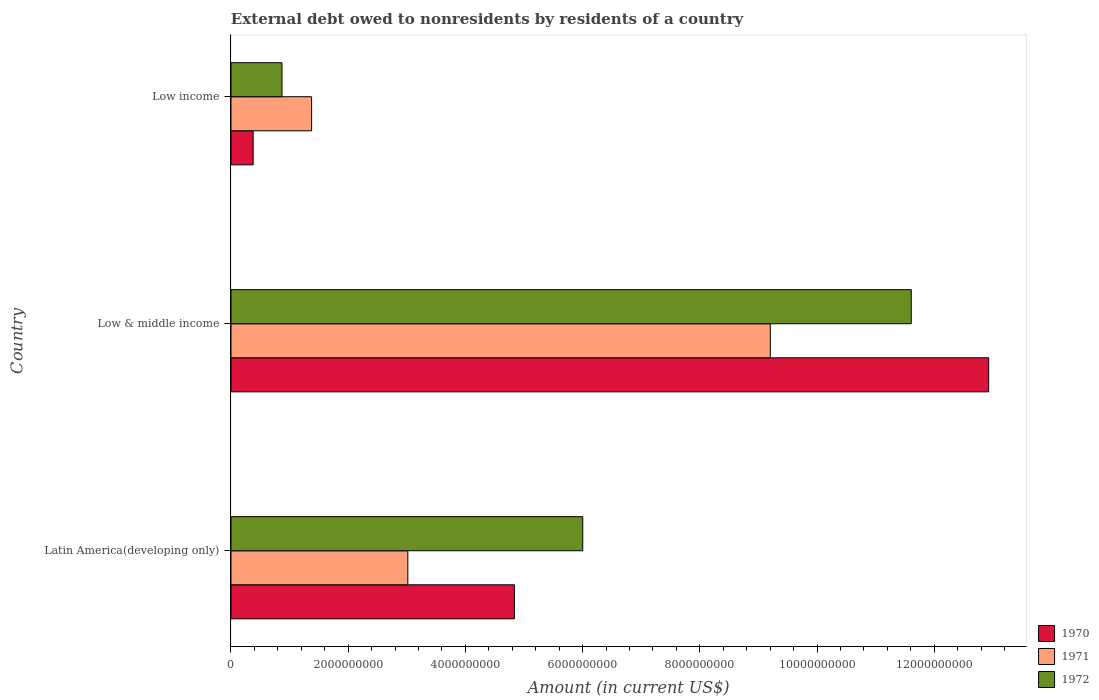How many different coloured bars are there?
Ensure brevity in your answer.  3. Are the number of bars per tick equal to the number of legend labels?
Offer a terse response. Yes. How many bars are there on the 1st tick from the top?
Provide a succinct answer. 3. In how many cases, is the number of bars for a given country not equal to the number of legend labels?
Provide a succinct answer. 0. What is the external debt owed by residents in 1972 in Latin America(developing only)?
Keep it short and to the point. 6.00e+09. Across all countries, what is the maximum external debt owed by residents in 1970?
Your response must be concise. 1.29e+1. Across all countries, what is the minimum external debt owed by residents in 1972?
Offer a very short reply. 8.71e+08. In which country was the external debt owed by residents in 1971 minimum?
Offer a very short reply. Low income. What is the total external debt owed by residents in 1972 in the graph?
Offer a very short reply. 1.85e+1. What is the difference between the external debt owed by residents in 1971 in Latin America(developing only) and that in Low & middle income?
Provide a short and direct response. -6.18e+09. What is the difference between the external debt owed by residents in 1971 in Latin America(developing only) and the external debt owed by residents in 1972 in Low & middle income?
Offer a very short reply. -8.59e+09. What is the average external debt owed by residents in 1972 per country?
Keep it short and to the point. 6.16e+09. What is the difference between the external debt owed by residents in 1972 and external debt owed by residents in 1971 in Latin America(developing only)?
Provide a succinct answer. 2.98e+09. In how many countries, is the external debt owed by residents in 1970 greater than 11600000000 US$?
Make the answer very short. 1. What is the ratio of the external debt owed by residents in 1972 in Latin America(developing only) to that in Low income?
Offer a very short reply. 6.89. Is the external debt owed by residents in 1971 in Latin America(developing only) less than that in Low & middle income?
Give a very brief answer. Yes. Is the difference between the external debt owed by residents in 1972 in Latin America(developing only) and Low & middle income greater than the difference between the external debt owed by residents in 1971 in Latin America(developing only) and Low & middle income?
Provide a short and direct response. Yes. What is the difference between the highest and the second highest external debt owed by residents in 1971?
Your answer should be very brief. 6.18e+09. What is the difference between the highest and the lowest external debt owed by residents in 1971?
Your answer should be compact. 7.83e+09. What is the difference between two consecutive major ticks on the X-axis?
Keep it short and to the point. 2.00e+09. Are the values on the major ticks of X-axis written in scientific E-notation?
Offer a terse response. No. Where does the legend appear in the graph?
Make the answer very short. Bottom right. How many legend labels are there?
Offer a very short reply. 3. How are the legend labels stacked?
Keep it short and to the point. Vertical. What is the title of the graph?
Give a very brief answer. External debt owed to nonresidents by residents of a country. What is the Amount (in current US$) of 1970 in Latin America(developing only)?
Ensure brevity in your answer.  4.84e+09. What is the Amount (in current US$) of 1971 in Latin America(developing only)?
Provide a short and direct response. 3.02e+09. What is the Amount (in current US$) in 1972 in Latin America(developing only)?
Ensure brevity in your answer.  6.00e+09. What is the Amount (in current US$) of 1970 in Low & middle income?
Provide a short and direct response. 1.29e+1. What is the Amount (in current US$) in 1971 in Low & middle income?
Offer a very short reply. 9.20e+09. What is the Amount (in current US$) in 1972 in Low & middle income?
Your response must be concise. 1.16e+1. What is the Amount (in current US$) in 1970 in Low income?
Keep it short and to the point. 3.78e+08. What is the Amount (in current US$) in 1971 in Low income?
Provide a succinct answer. 1.38e+09. What is the Amount (in current US$) in 1972 in Low income?
Your response must be concise. 8.71e+08. Across all countries, what is the maximum Amount (in current US$) in 1970?
Your answer should be compact. 1.29e+1. Across all countries, what is the maximum Amount (in current US$) of 1971?
Make the answer very short. 9.20e+09. Across all countries, what is the maximum Amount (in current US$) of 1972?
Offer a very short reply. 1.16e+1. Across all countries, what is the minimum Amount (in current US$) in 1970?
Offer a very short reply. 3.78e+08. Across all countries, what is the minimum Amount (in current US$) in 1971?
Your answer should be compact. 1.38e+09. Across all countries, what is the minimum Amount (in current US$) of 1972?
Ensure brevity in your answer.  8.71e+08. What is the total Amount (in current US$) of 1970 in the graph?
Your response must be concise. 1.81e+1. What is the total Amount (in current US$) in 1971 in the graph?
Provide a succinct answer. 1.36e+1. What is the total Amount (in current US$) of 1972 in the graph?
Offer a terse response. 1.85e+1. What is the difference between the Amount (in current US$) in 1970 in Latin America(developing only) and that in Low & middle income?
Give a very brief answer. -8.09e+09. What is the difference between the Amount (in current US$) of 1971 in Latin America(developing only) and that in Low & middle income?
Your answer should be very brief. -6.18e+09. What is the difference between the Amount (in current US$) of 1972 in Latin America(developing only) and that in Low & middle income?
Your answer should be very brief. -5.61e+09. What is the difference between the Amount (in current US$) in 1970 in Latin America(developing only) and that in Low income?
Give a very brief answer. 4.46e+09. What is the difference between the Amount (in current US$) of 1971 in Latin America(developing only) and that in Low income?
Your answer should be very brief. 1.64e+09. What is the difference between the Amount (in current US$) in 1972 in Latin America(developing only) and that in Low income?
Give a very brief answer. 5.13e+09. What is the difference between the Amount (in current US$) in 1970 in Low & middle income and that in Low income?
Your answer should be very brief. 1.25e+1. What is the difference between the Amount (in current US$) of 1971 in Low & middle income and that in Low income?
Your response must be concise. 7.83e+09. What is the difference between the Amount (in current US$) in 1972 in Low & middle income and that in Low income?
Provide a short and direct response. 1.07e+1. What is the difference between the Amount (in current US$) in 1970 in Latin America(developing only) and the Amount (in current US$) in 1971 in Low & middle income?
Your response must be concise. -4.37e+09. What is the difference between the Amount (in current US$) in 1970 in Latin America(developing only) and the Amount (in current US$) in 1972 in Low & middle income?
Offer a very short reply. -6.77e+09. What is the difference between the Amount (in current US$) in 1971 in Latin America(developing only) and the Amount (in current US$) in 1972 in Low & middle income?
Make the answer very short. -8.59e+09. What is the difference between the Amount (in current US$) of 1970 in Latin America(developing only) and the Amount (in current US$) of 1971 in Low income?
Your answer should be compact. 3.46e+09. What is the difference between the Amount (in current US$) in 1970 in Latin America(developing only) and the Amount (in current US$) in 1972 in Low income?
Your answer should be compact. 3.97e+09. What is the difference between the Amount (in current US$) of 1971 in Latin America(developing only) and the Amount (in current US$) of 1972 in Low income?
Provide a short and direct response. 2.15e+09. What is the difference between the Amount (in current US$) of 1970 in Low & middle income and the Amount (in current US$) of 1971 in Low income?
Provide a succinct answer. 1.16e+1. What is the difference between the Amount (in current US$) in 1970 in Low & middle income and the Amount (in current US$) in 1972 in Low income?
Your answer should be very brief. 1.21e+1. What is the difference between the Amount (in current US$) in 1971 in Low & middle income and the Amount (in current US$) in 1972 in Low income?
Offer a very short reply. 8.33e+09. What is the average Amount (in current US$) in 1970 per country?
Provide a short and direct response. 6.05e+09. What is the average Amount (in current US$) of 1971 per country?
Keep it short and to the point. 4.53e+09. What is the average Amount (in current US$) of 1972 per country?
Ensure brevity in your answer.  6.16e+09. What is the difference between the Amount (in current US$) of 1970 and Amount (in current US$) of 1971 in Latin America(developing only)?
Give a very brief answer. 1.82e+09. What is the difference between the Amount (in current US$) of 1970 and Amount (in current US$) of 1972 in Latin America(developing only)?
Offer a terse response. -1.17e+09. What is the difference between the Amount (in current US$) of 1971 and Amount (in current US$) of 1972 in Latin America(developing only)?
Provide a succinct answer. -2.98e+09. What is the difference between the Amount (in current US$) in 1970 and Amount (in current US$) in 1971 in Low & middle income?
Your answer should be compact. 3.73e+09. What is the difference between the Amount (in current US$) of 1970 and Amount (in current US$) of 1972 in Low & middle income?
Provide a succinct answer. 1.32e+09. What is the difference between the Amount (in current US$) in 1971 and Amount (in current US$) in 1972 in Low & middle income?
Your response must be concise. -2.41e+09. What is the difference between the Amount (in current US$) of 1970 and Amount (in current US$) of 1971 in Low income?
Make the answer very short. -9.97e+08. What is the difference between the Amount (in current US$) of 1970 and Amount (in current US$) of 1972 in Low income?
Provide a short and direct response. -4.92e+08. What is the difference between the Amount (in current US$) in 1971 and Amount (in current US$) in 1972 in Low income?
Provide a succinct answer. 5.05e+08. What is the ratio of the Amount (in current US$) in 1970 in Latin America(developing only) to that in Low & middle income?
Give a very brief answer. 0.37. What is the ratio of the Amount (in current US$) of 1971 in Latin America(developing only) to that in Low & middle income?
Offer a very short reply. 0.33. What is the ratio of the Amount (in current US$) of 1972 in Latin America(developing only) to that in Low & middle income?
Give a very brief answer. 0.52. What is the ratio of the Amount (in current US$) in 1970 in Latin America(developing only) to that in Low income?
Provide a succinct answer. 12.78. What is the ratio of the Amount (in current US$) of 1971 in Latin America(developing only) to that in Low income?
Keep it short and to the point. 2.19. What is the ratio of the Amount (in current US$) of 1972 in Latin America(developing only) to that in Low income?
Your answer should be very brief. 6.89. What is the ratio of the Amount (in current US$) of 1970 in Low & middle income to that in Low income?
Provide a short and direct response. 34.16. What is the ratio of the Amount (in current US$) in 1971 in Low & middle income to that in Low income?
Ensure brevity in your answer.  6.69. What is the ratio of the Amount (in current US$) in 1972 in Low & middle income to that in Low income?
Ensure brevity in your answer.  13.33. What is the difference between the highest and the second highest Amount (in current US$) of 1970?
Provide a succinct answer. 8.09e+09. What is the difference between the highest and the second highest Amount (in current US$) of 1971?
Offer a very short reply. 6.18e+09. What is the difference between the highest and the second highest Amount (in current US$) in 1972?
Ensure brevity in your answer.  5.61e+09. What is the difference between the highest and the lowest Amount (in current US$) in 1970?
Provide a short and direct response. 1.25e+1. What is the difference between the highest and the lowest Amount (in current US$) in 1971?
Provide a short and direct response. 7.83e+09. What is the difference between the highest and the lowest Amount (in current US$) of 1972?
Keep it short and to the point. 1.07e+1. 